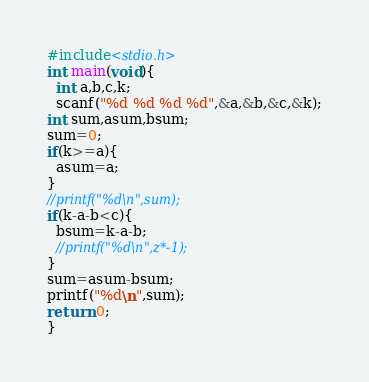<code> <loc_0><loc_0><loc_500><loc_500><_C_>#include<stdio.h>
int main(void){
  int a,b,c,k;
  scanf("%d %d %d %d",&a,&b,&c,&k);
int sum,asum,bsum;
sum=0;
if(k>=a){
  asum=a;
}
//printf("%d\n",sum);
if(k-a-b<c){
  bsum=k-a-b;
  //printf("%d\n",z*-1);
}
sum=asum-bsum;
printf("%d\n",sum);
return 0;
}
</code> 